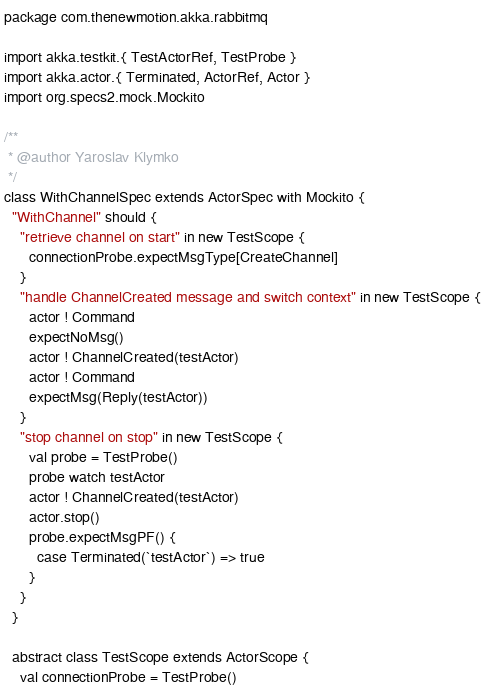<code> <loc_0><loc_0><loc_500><loc_500><_Scala_>package com.thenewmotion.akka.rabbitmq

import akka.testkit.{ TestActorRef, TestProbe }
import akka.actor.{ Terminated, ActorRef, Actor }
import org.specs2.mock.Mockito

/**
 * @author Yaroslav Klymko
 */
class WithChannelSpec extends ActorSpec with Mockito {
  "WithChannel" should {
    "retrieve channel on start" in new TestScope {
      connectionProbe.expectMsgType[CreateChannel]
    }
    "handle ChannelCreated message and switch context" in new TestScope {
      actor ! Command
      expectNoMsg()
      actor ! ChannelCreated(testActor)
      actor ! Command
      expectMsg(Reply(testActor))
    }
    "stop channel on stop" in new TestScope {
      val probe = TestProbe()
      probe watch testActor
      actor ! ChannelCreated(testActor)
      actor.stop()
      probe.expectMsgPF() {
        case Terminated(`testActor`) => true
      }
    }
  }

  abstract class TestScope extends ActorScope {
    val connectionProbe = TestProbe()</code> 